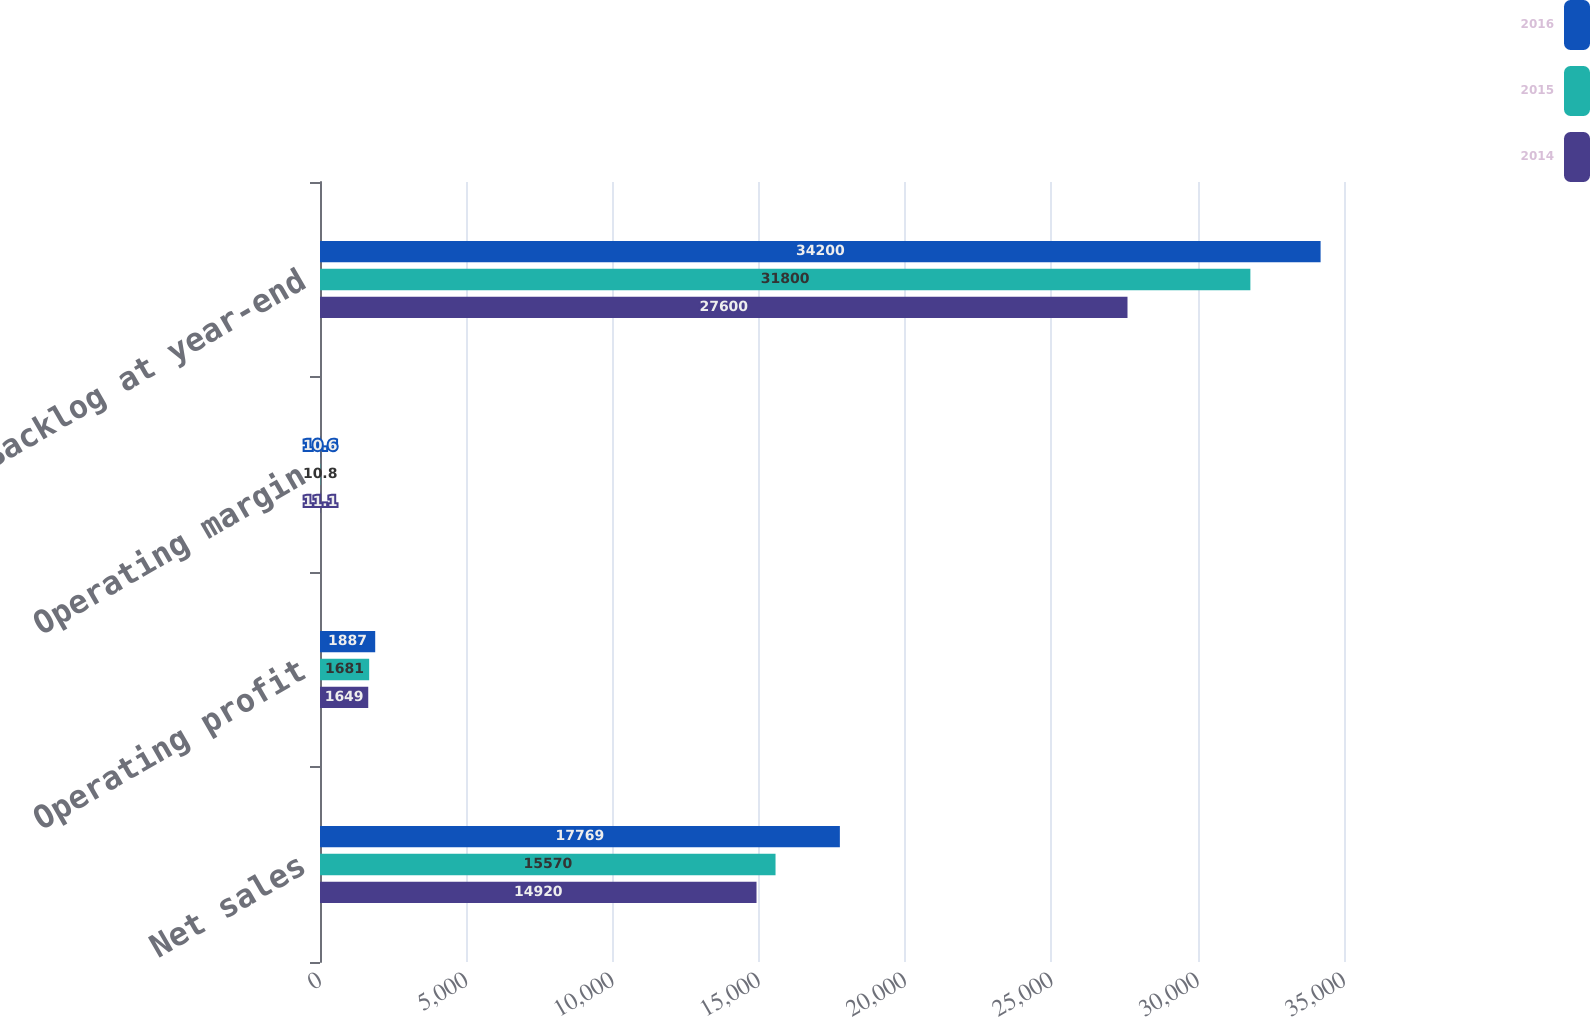Convert chart to OTSL. <chart><loc_0><loc_0><loc_500><loc_500><stacked_bar_chart><ecel><fcel>Net sales<fcel>Operating profit<fcel>Operating margin<fcel>Backlog at year-end<nl><fcel>2016<fcel>17769<fcel>1887<fcel>10.6<fcel>34200<nl><fcel>2015<fcel>15570<fcel>1681<fcel>10.8<fcel>31800<nl><fcel>2014<fcel>14920<fcel>1649<fcel>11.1<fcel>27600<nl></chart> 